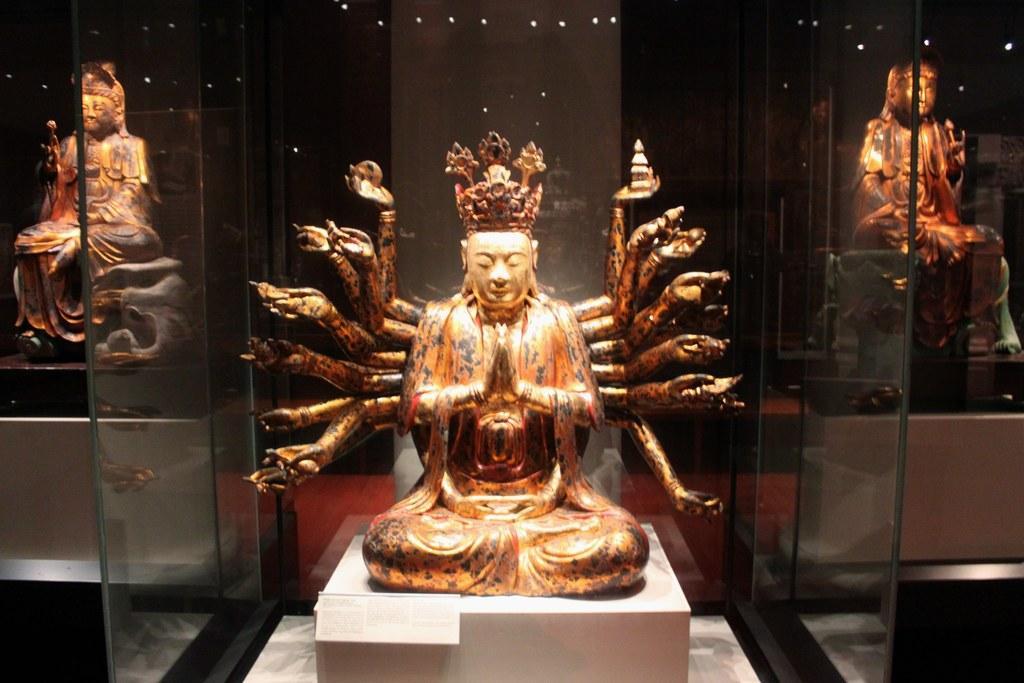Can you describe this image briefly? This picture is clicked inside the room and we can see the sculptures of persons holding some objects and sitting. In the background we can see the wall and the lights and the glasses. 